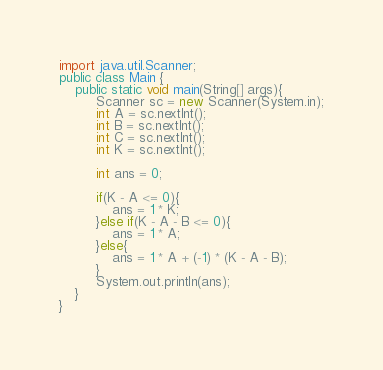<code> <loc_0><loc_0><loc_500><loc_500><_Java_>import java.util.Scanner;
public class Main {
    public static void main(String[] args){
         Scanner sc = new Scanner(System.in);
         int A = sc.nextInt();
         int B = sc.nextInt();
         int C = sc.nextInt();
         int K = sc.nextInt();
         
         int ans = 0;
         
         if(K - A <= 0){
             ans = 1 * K;
         }else if(K - A - B <= 0){
             ans = 1 * A;
         }else{
             ans = 1 * A + (-1) * (K - A - B);
         }
         System.out.println(ans);
    }
}</code> 